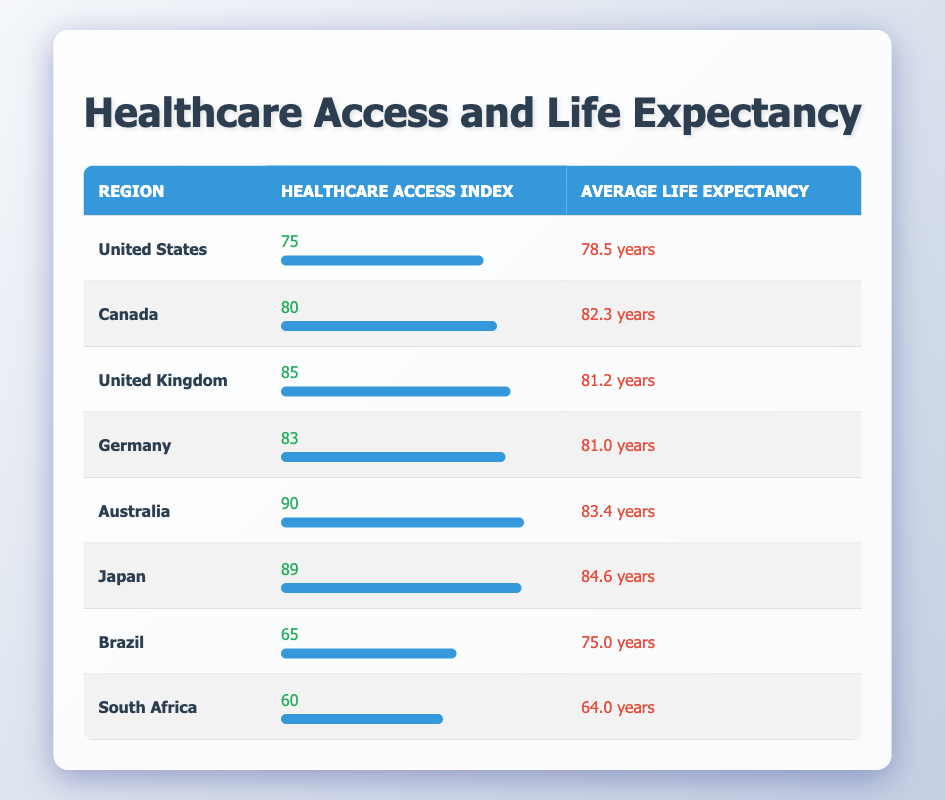What is the average life expectancy for regions with a healthcare access index above 80? The regions with a healthcare access index above 80 are Canada (82.3), United Kingdom (81.2), Germany (81.0), Australia (83.4), and Japan (84.6). To find the average, I sum these life expectancies: 82.3 + 81.2 + 81.0 + 83.4 + 84.6 = 412.5. Then, I divide by the number of regions, which is 5, resulting in 412.5 / 5 = 82.5.
Answer: 82.5 Which region has the highest healthcare access index? Looking at the table, the healthcare access indices are: United States (75), Canada (80), United Kingdom (85), Germany (83), Australia (90), Japan (89), Brazil (65), and South Africa (60). The maximum value is 90, which belongs to Australia.
Answer: Australia Is there a correlation between healthcare access and life expectancy based on the table? To evaluate this, I can observe the trend between the healthcare access index and average life expectancy. Generally, regions with higher indices (e.g., Australia and Japan with 90 and 89, corresponding life expectancies of 83.4 and 84.6) tend to have higher life expectancies. Conversely, South Africa has a low index (60) with a low life expectancy (64.0). This pattern suggests a positive correlation.
Answer: Yes What is the difference in average life expectancy between the region with the highest and lowest healthcare access index? The region with the highest healthcare access index is Australia (90) with an average life expectancy of 83.4. The region with the lowest index is South Africa (60) with an average life expectancy of 64.0. The difference is calculated by subtracting 64.0 from 83.4, resulting in 83.4 - 64.0 = 19.4.
Answer: 19.4 Are the average life expectancies in Canada and Australia closer together than those in Brazil and South Africa? The average life expectancy for Canada is 82.3 and for Australia is 83.4, giving a difference of 83.4 - 82.3 = 1.1. For Brazil, the average is 75.0, and for South Africa, it is 64.0, with a difference of 75.0 - 64.0 = 11.0. Comparing both differences, 1.1 is less than 11.0.
Answer: Yes What is the average healthcare access index for all regions listed? To calculate the average healthcare access index, I sum the indices: 75 + 80 + 85 + 83 + 90 + 89 + 65 + 60 = 727. Then, I divide by the number of regions, which is 8, resulting in 727 / 8 = 90.875.
Answer: 90.875 